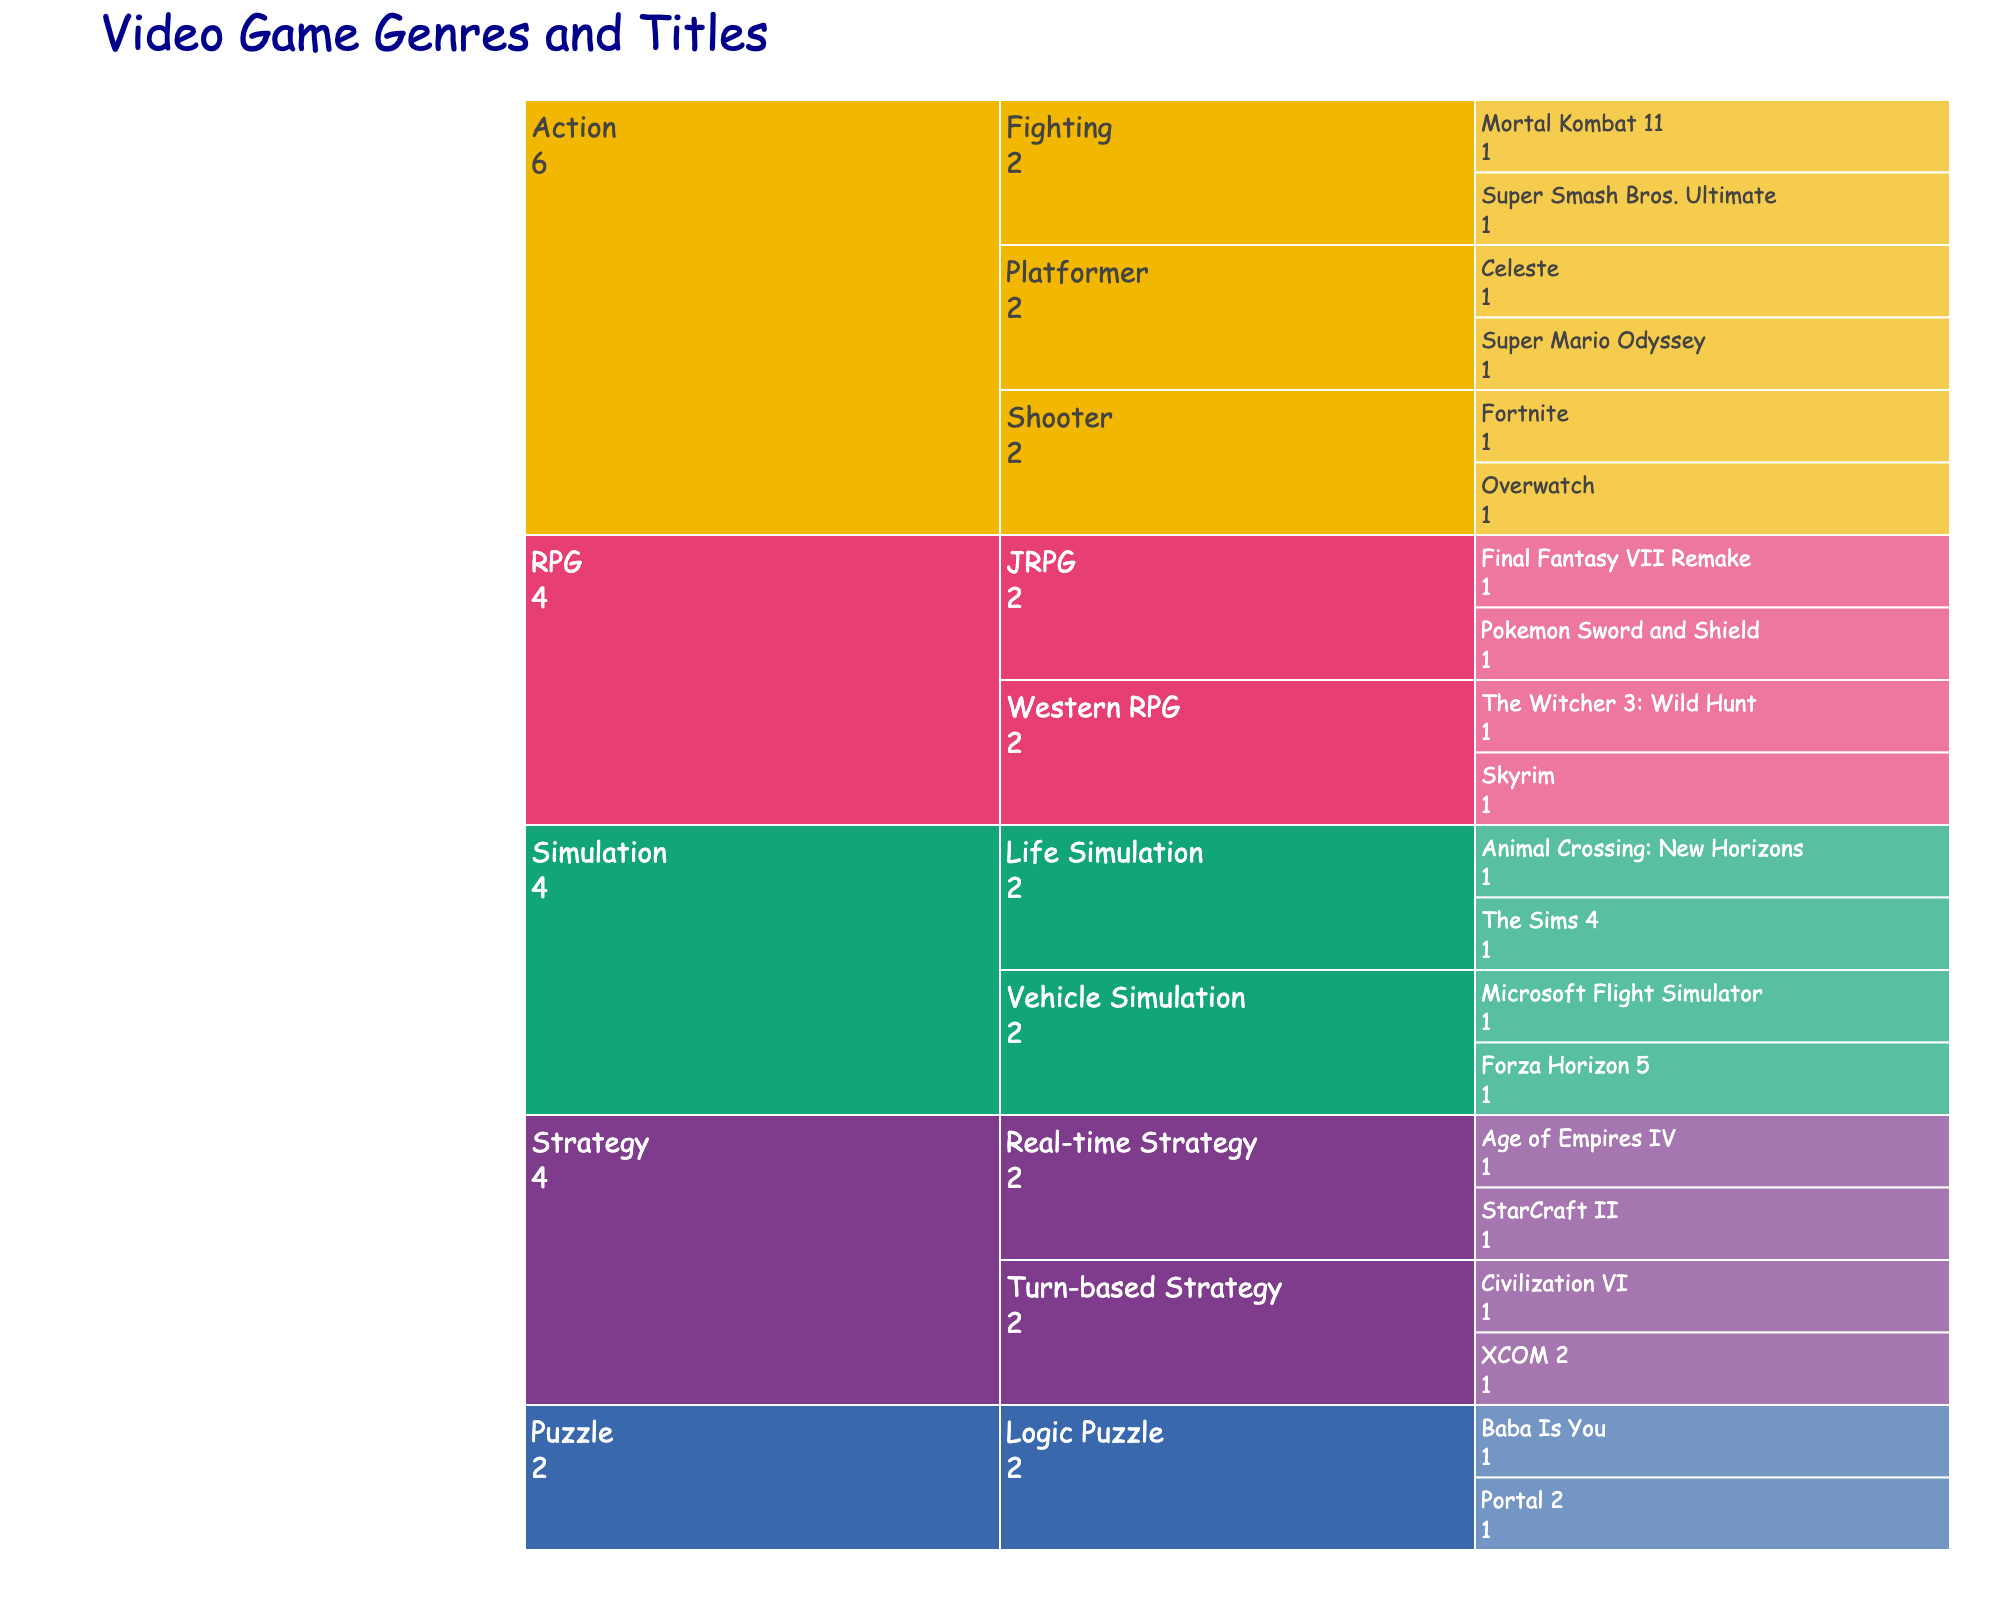What is the main title of the Icicle Chart? The main title is displayed at the top of the chart and typically summarizes the content visually represented.
Answer: Video Game Genres and Titles Which category has the most subcategories? Identify the primary categories and count their subcategories to determine which one has the highest count.
Answer: Action How many titles are listed under the "RPG" category? Count the individual titles under the "RPG" category shown on the chart.
Answer: 4 Compare the number of titles under "Strategy" and "Simulation". Which has more? Count the titles under both "Strategy" and "Simulation" and compare their counts.
Answer: They both have 4 titles What color is used to represent the "Puzzle" category? Look at the color coding on the chart; each category has a distinct color.
Answer: [Answer depends on the specific rendering but should mention the exact color by name if possible, e.g., orange] Which subcategory has the title "The Sims 4"? Locate "The Sims 4" on the chart and trace back to its subcategory.
Answer: Life Simulation Which Action subcategory has more titles, Platformer or Shooter? Count the titles in the Platformer and Shooter subcategories under Action and compare the counts.
Answer: Platformer has more (2 titles) Are there more JRPG titles or Western RPG titles in the RPG category? Count the titles in the JRPG and Western RPG subcategories and compare them.
Answer: JRPG (2 titles) How many video game titles are listed in total? Count all the entries across all the categories and subcategories in the chart.
Answer: 18 What subcategory is the title "Civilization VI" under, and what category does it belong to? You'll need to track back "Civilization VI" to find its subcategory and the main category it belongs to.
Answer: Turn-based Strategy, Strategy 